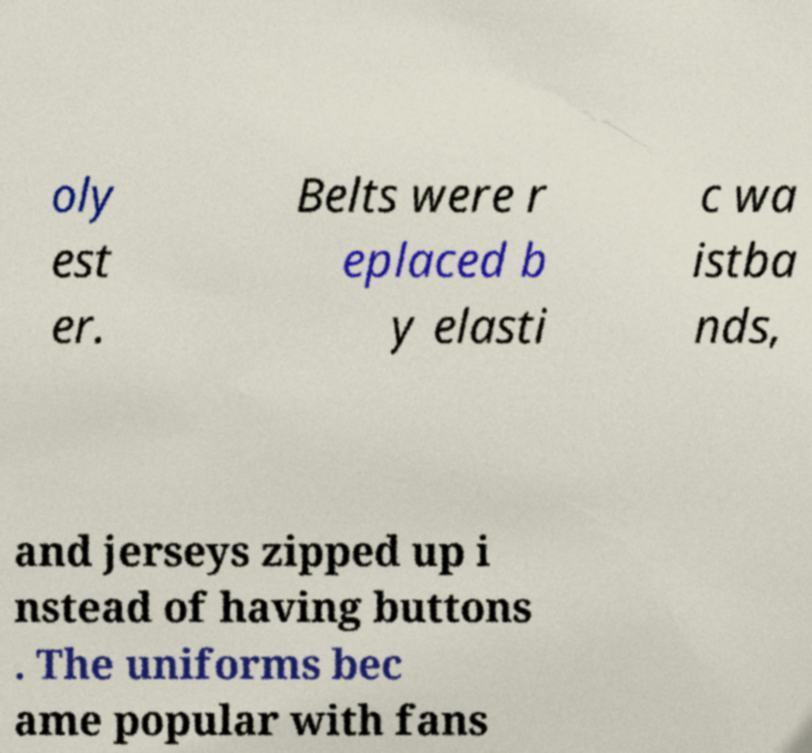Can you read and provide the text displayed in the image?This photo seems to have some interesting text. Can you extract and type it out for me? oly est er. Belts were r eplaced b y elasti c wa istba nds, and jerseys zipped up i nstead of having buttons . The uniforms bec ame popular with fans 